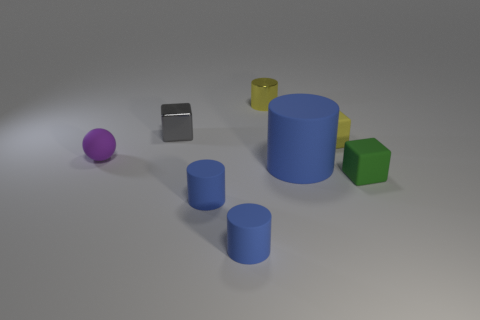Subtract all brown blocks. How many blue cylinders are left? 3 Subtract 1 cylinders. How many cylinders are left? 3 Subtract all blue cylinders. Subtract all purple spheres. How many cylinders are left? 1 Add 1 small yellow objects. How many objects exist? 9 Subtract all cubes. How many objects are left? 5 Subtract 0 cyan balls. How many objects are left? 8 Subtract all small green matte cubes. Subtract all small red rubber balls. How many objects are left? 7 Add 7 tiny yellow metal cylinders. How many tiny yellow metal cylinders are left? 8 Add 2 tiny yellow cylinders. How many tiny yellow cylinders exist? 3 